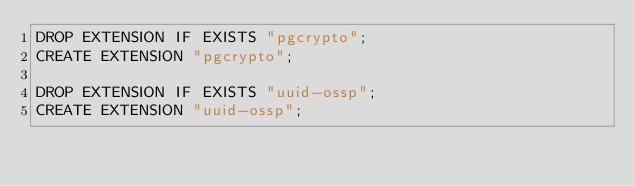Convert code to text. <code><loc_0><loc_0><loc_500><loc_500><_SQL_>DROP EXTENSION IF EXISTS "pgcrypto";
CREATE EXTENSION "pgcrypto";

DROP EXTENSION IF EXISTS "uuid-ossp";
CREATE EXTENSION "uuid-ossp";</code> 